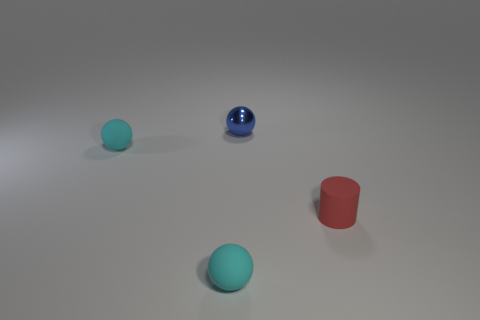Is there anything else that is the same material as the tiny blue object?
Offer a very short reply. No. There is a small cyan ball in front of the tiny thing that is to the right of the shiny object; how many matte spheres are to the left of it?
Your response must be concise. 1. There is a red matte cylinder; are there any rubber balls behind it?
Offer a terse response. Yes. How many cyan objects have the same material as the red cylinder?
Provide a short and direct response. 2. How many things are small cyan matte things or purple matte cubes?
Offer a very short reply. 2. Are there any blue shiny balls?
Provide a short and direct response. Yes. What is the material of the small ball that is behind the cyan rubber object that is on the left side of the small cyan object that is in front of the red matte object?
Keep it short and to the point. Metal. Are there fewer tiny things behind the red rubber thing than cylinders?
Ensure brevity in your answer.  No. There is a cylinder that is the same size as the blue shiny object; what material is it?
Keep it short and to the point. Rubber. There is a sphere that is both behind the red rubber object and in front of the tiny blue metallic sphere; what size is it?
Your answer should be very brief. Small. 